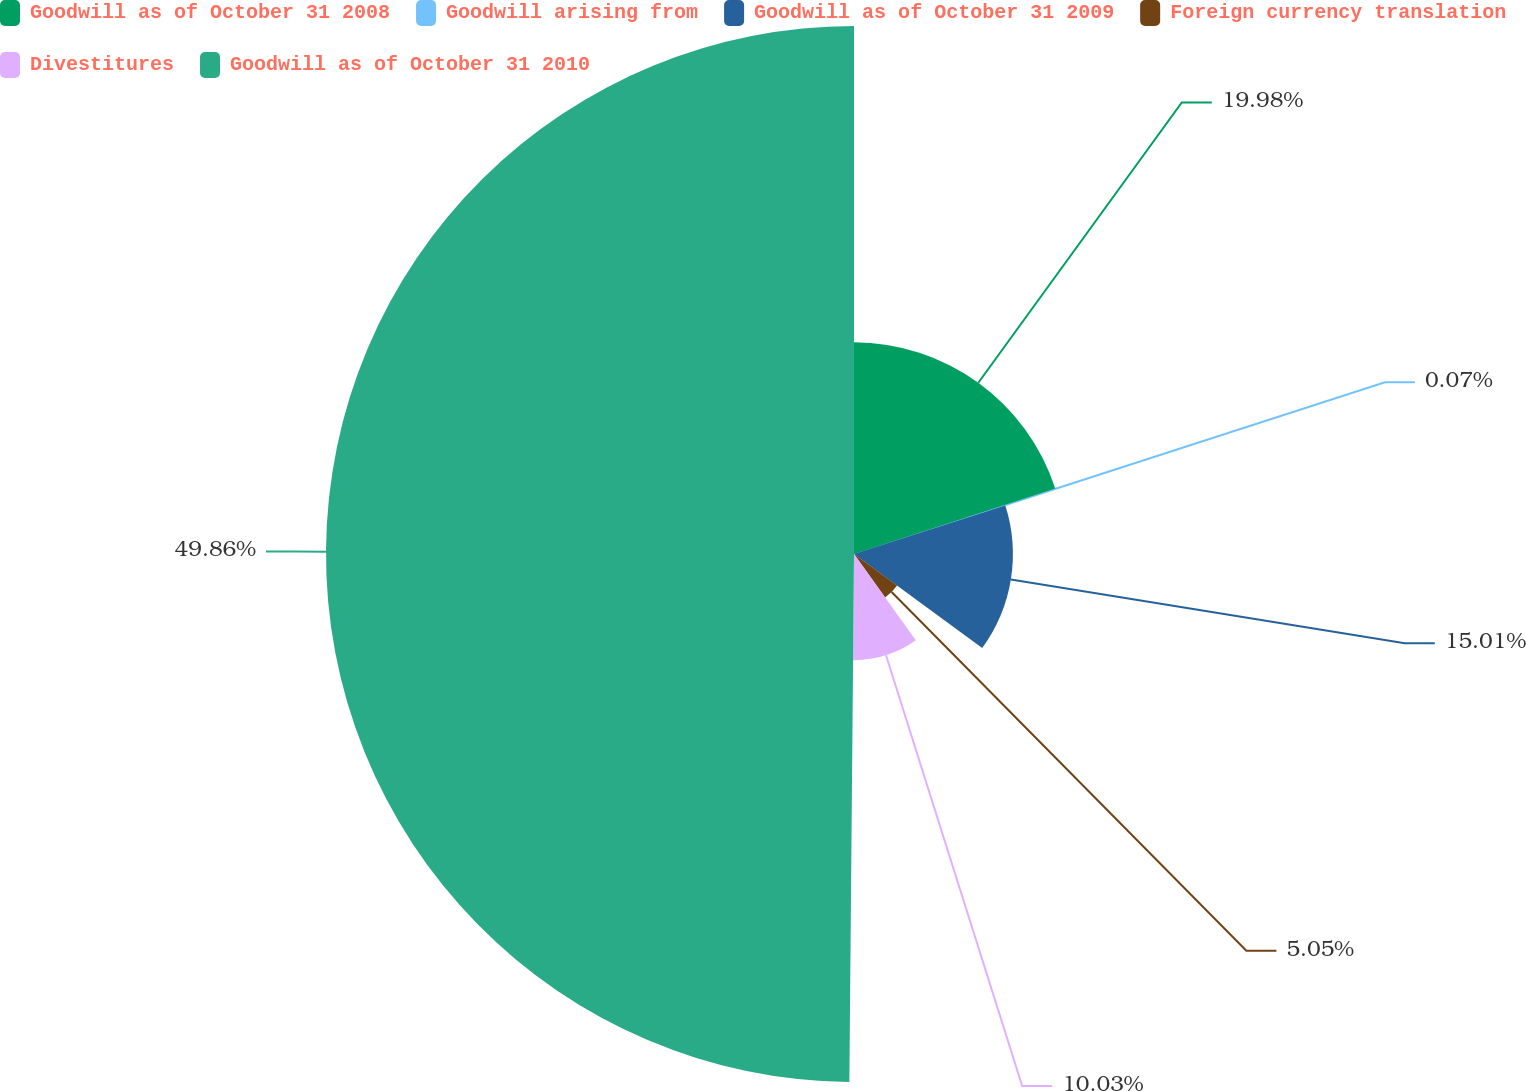<chart> <loc_0><loc_0><loc_500><loc_500><pie_chart><fcel>Goodwill as of October 31 2008<fcel>Goodwill arising from<fcel>Goodwill as of October 31 2009<fcel>Foreign currency translation<fcel>Divestitures<fcel>Goodwill as of October 31 2010<nl><fcel>19.99%<fcel>0.07%<fcel>15.01%<fcel>5.05%<fcel>10.03%<fcel>49.87%<nl></chart> 